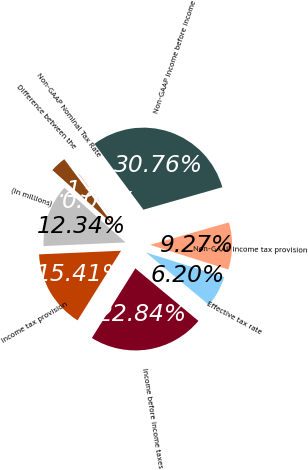Convert chart to OTSL. <chart><loc_0><loc_0><loc_500><loc_500><pie_chart><fcel>(in millions)<fcel>Income tax provision<fcel>Income before income taxes<fcel>Effective tax rate<fcel>Non-GAAP income tax provision<fcel>Non-GAAP income before income<fcel>Non-GAAP Nominal Tax Rate<fcel>Difference between the<nl><fcel>12.34%<fcel>15.41%<fcel>22.84%<fcel>6.2%<fcel>9.27%<fcel>30.76%<fcel>0.06%<fcel>3.13%<nl></chart> 